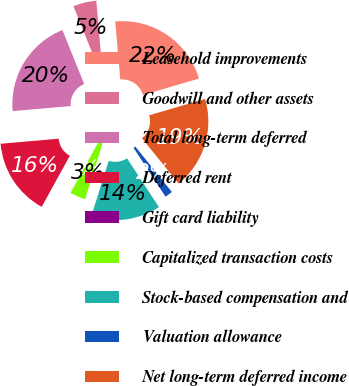<chart> <loc_0><loc_0><loc_500><loc_500><pie_chart><fcel>Leasehold improvements<fcel>Goodwill and other assets<fcel>Total long-term deferred<fcel>Deferred rent<fcel>Gift card liability<fcel>Capitalized transaction costs<fcel>Stock-based compensation and<fcel>Valuation allowance<fcel>Net long-term deferred income<nl><fcel>21.86%<fcel>4.7%<fcel>20.3%<fcel>15.62%<fcel>0.02%<fcel>3.14%<fcel>14.06%<fcel>1.58%<fcel>18.74%<nl></chart> 